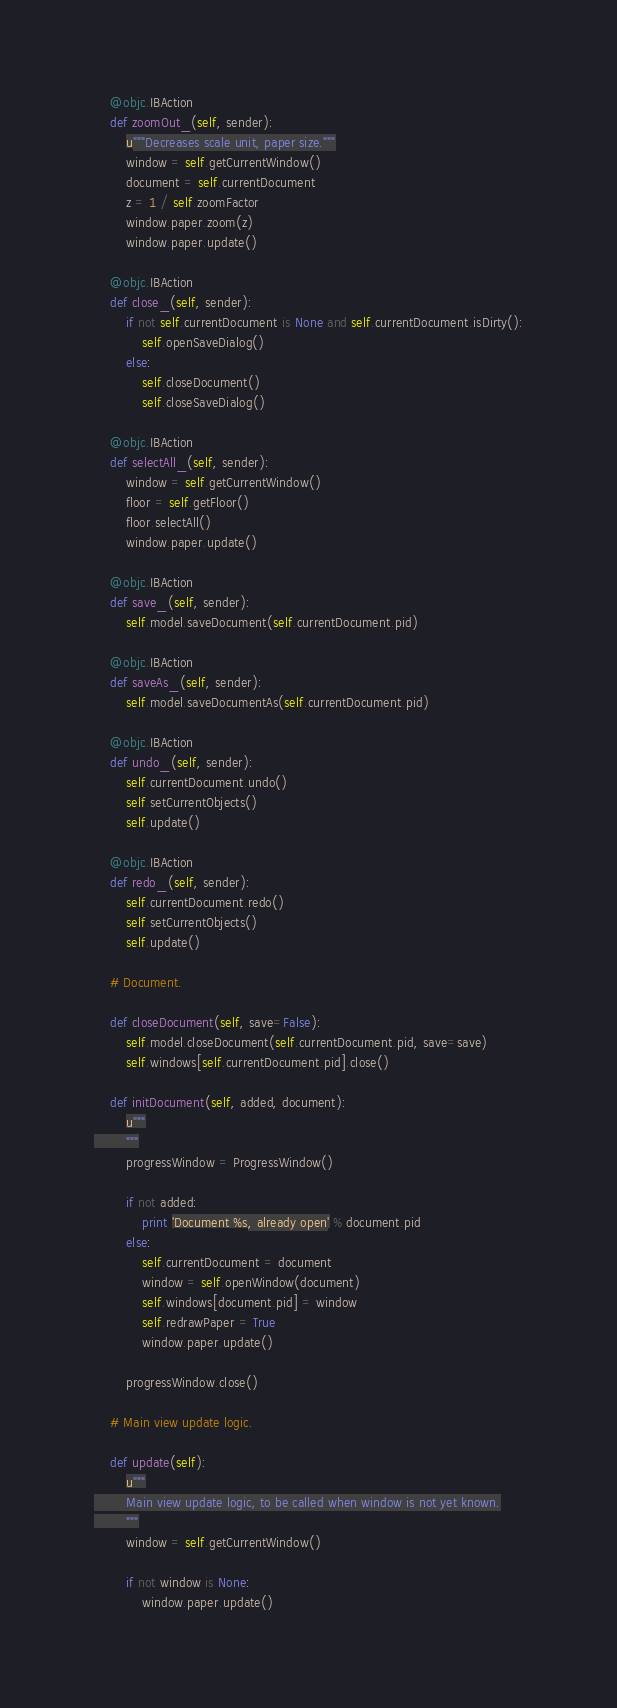Convert code to text. <code><loc_0><loc_0><loc_500><loc_500><_Python_>    @objc.IBAction
    def zoomOut_(self, sender):
        u"""Decreases scale unit, paper size."""
        window = self.getCurrentWindow()
        document = self.currentDocument
        z = 1 / self.zoomFactor
        window.paper.zoom(z)
        window.paper.update()

    @objc.IBAction
    def close_(self, sender):
        if not self.currentDocument is None and self.currentDocument.isDirty():
            self.openSaveDialog()
        else:
            self.closeDocument()
            self.closeSaveDialog()

    @objc.IBAction
    def selectAll_(self, sender):
        window = self.getCurrentWindow()
        floor = self.getFloor()
        floor.selectAll()
        window.paper.update()

    @objc.IBAction
    def save_(self, sender):
        self.model.saveDocument(self.currentDocument.pid)

    @objc.IBAction
    def saveAs_(self, sender):
        self.model.saveDocumentAs(self.currentDocument.pid)

    @objc.IBAction
    def undo_(self, sender):
        self.currentDocument.undo()
        self.setCurrentObjects()
        self.update()

    @objc.IBAction
    def redo_(self, sender):
        self.currentDocument.redo()
        self.setCurrentObjects()
        self.update()

    # Document.

    def closeDocument(self, save=False):
        self.model.closeDocument(self.currentDocument.pid, save=save)
        self.windows[self.currentDocument.pid].close()

    def initDocument(self, added, document):
        u"""
        """
        progressWindow = ProgressWindow()

        if not added:
            print 'Document %s, already open' % document.pid
        else:
            self.currentDocument = document
            window = self.openWindow(document)
            self.windows[document.pid] = window
            self.redrawPaper = True
            window.paper.update()

        progressWindow.close()

    # Main view update logic.

    def update(self):
        u"""
        Main view update logic, to be called when window is not yet known.
        """
        window = self.getCurrentWindow()

        if not window is None:
            window.paper.update()
</code> 